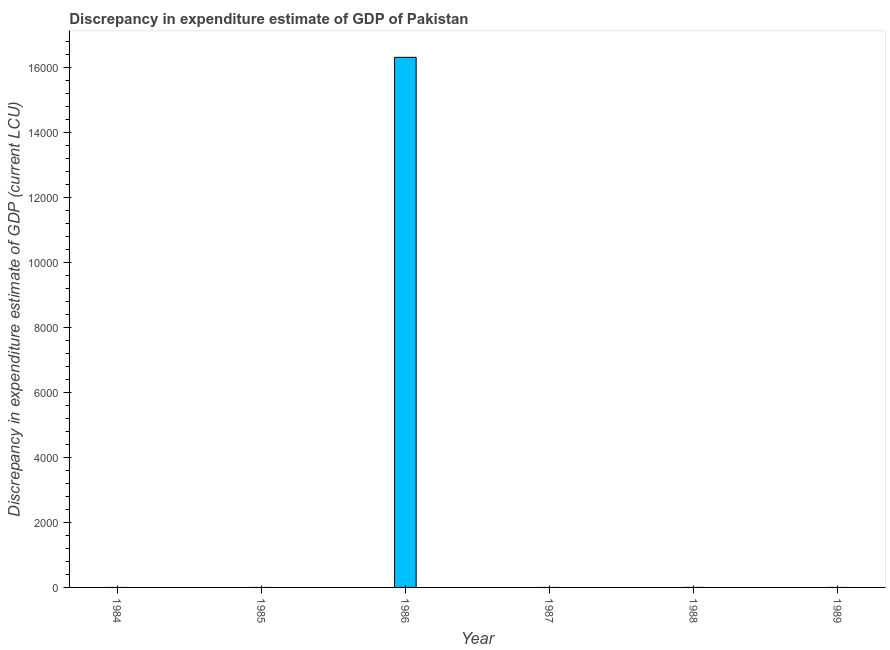Does the graph contain grids?
Your answer should be very brief. No. What is the title of the graph?
Your answer should be very brief. Discrepancy in expenditure estimate of GDP of Pakistan. What is the label or title of the Y-axis?
Your answer should be very brief. Discrepancy in expenditure estimate of GDP (current LCU). Across all years, what is the maximum discrepancy in expenditure estimate of gdp?
Make the answer very short. 1.63e+04. Across all years, what is the minimum discrepancy in expenditure estimate of gdp?
Offer a very short reply. 0. In which year was the discrepancy in expenditure estimate of gdp maximum?
Your answer should be very brief. 1986. What is the sum of the discrepancy in expenditure estimate of gdp?
Ensure brevity in your answer.  1.63e+04. What is the average discrepancy in expenditure estimate of gdp per year?
Offer a very short reply. 2716.67. In how many years, is the discrepancy in expenditure estimate of gdp greater than 14000 LCU?
Offer a very short reply. 1. What is the difference between the highest and the lowest discrepancy in expenditure estimate of gdp?
Your answer should be compact. 1.63e+04. How many bars are there?
Ensure brevity in your answer.  1. What is the difference between two consecutive major ticks on the Y-axis?
Give a very brief answer. 2000. Are the values on the major ticks of Y-axis written in scientific E-notation?
Make the answer very short. No. What is the Discrepancy in expenditure estimate of GDP (current LCU) of 1984?
Provide a short and direct response. 0. What is the Discrepancy in expenditure estimate of GDP (current LCU) of 1985?
Make the answer very short. 0. What is the Discrepancy in expenditure estimate of GDP (current LCU) of 1986?
Your answer should be very brief. 1.63e+04. What is the Discrepancy in expenditure estimate of GDP (current LCU) in 1988?
Keep it short and to the point. 0. 